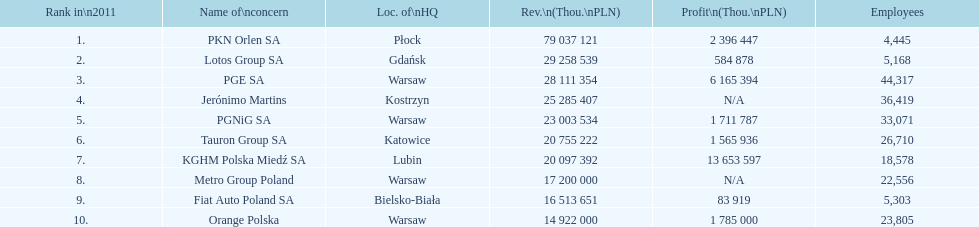What is the number of employees who work for pgnig sa? 33,071. 